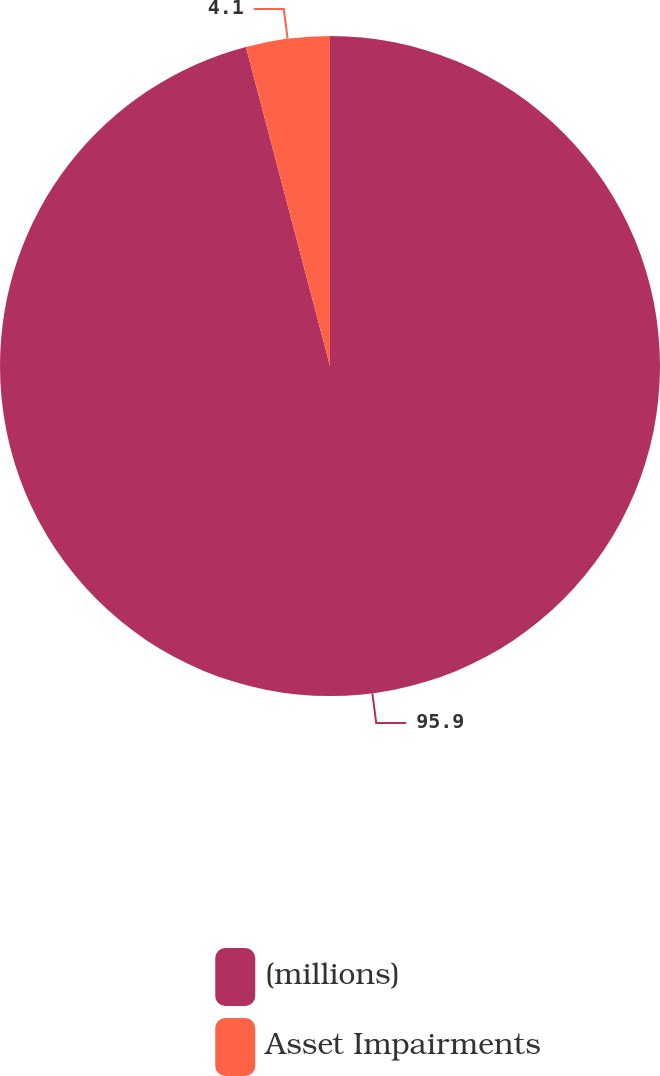<chart> <loc_0><loc_0><loc_500><loc_500><pie_chart><fcel>(millions)<fcel>Asset Impairments<nl><fcel>95.9%<fcel>4.1%<nl></chart> 